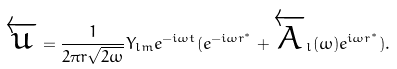Convert formula to latex. <formula><loc_0><loc_0><loc_500><loc_500>\overleftarrow { u } = \frac { 1 } { 2 \pi r \sqrt { 2 \omega } } Y _ { l m } e ^ { - i \omega t } ( e ^ { - i \omega r ^ { * } } + \overleftarrow { A } _ { l } ( \omega ) e ^ { i \omega r ^ { * } } ) .</formula> 